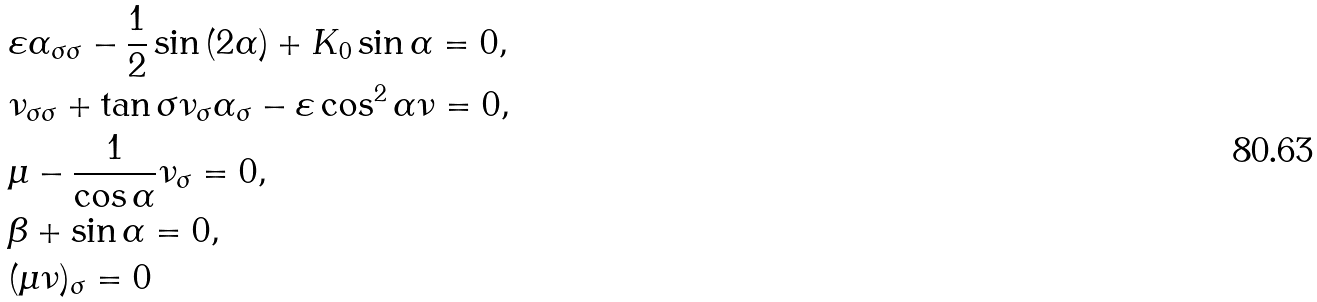<formula> <loc_0><loc_0><loc_500><loc_500>& \varepsilon \alpha _ { \sigma \sigma } - \frac { 1 } { 2 } \sin { ( 2 \alpha ) } + K _ { 0 } \sin { \alpha } = 0 , \\ & \nu _ { \sigma \sigma } + \tan { \sigma } \nu _ { \sigma } \alpha _ { \sigma } - \varepsilon \cos ^ { 2 } { \alpha } \nu = 0 , \\ & \mu - \frac { 1 } { \cos { \alpha } } \nu _ { \sigma } = 0 , \\ & \beta + \sin { \alpha } = 0 , \\ & ( \mu \nu ) _ { \sigma } = 0</formula> 